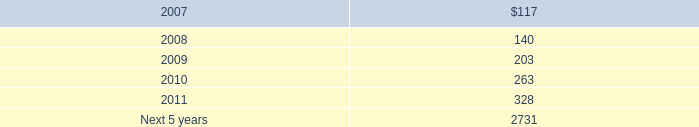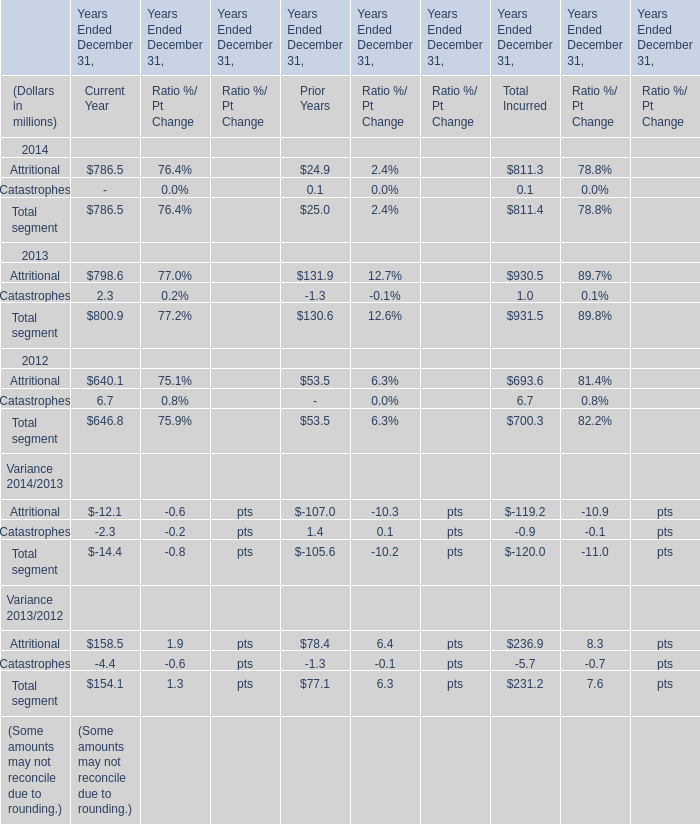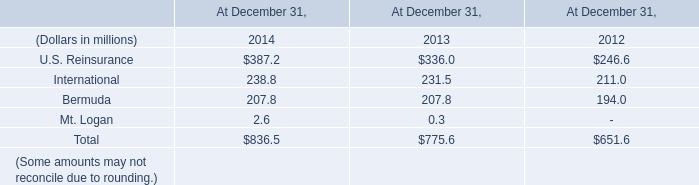What's the total amount of the Current Year in the years where Total segment greater than 800? (in million) 
Computations: (786.5 + 800.9)
Answer: 1587.4. 